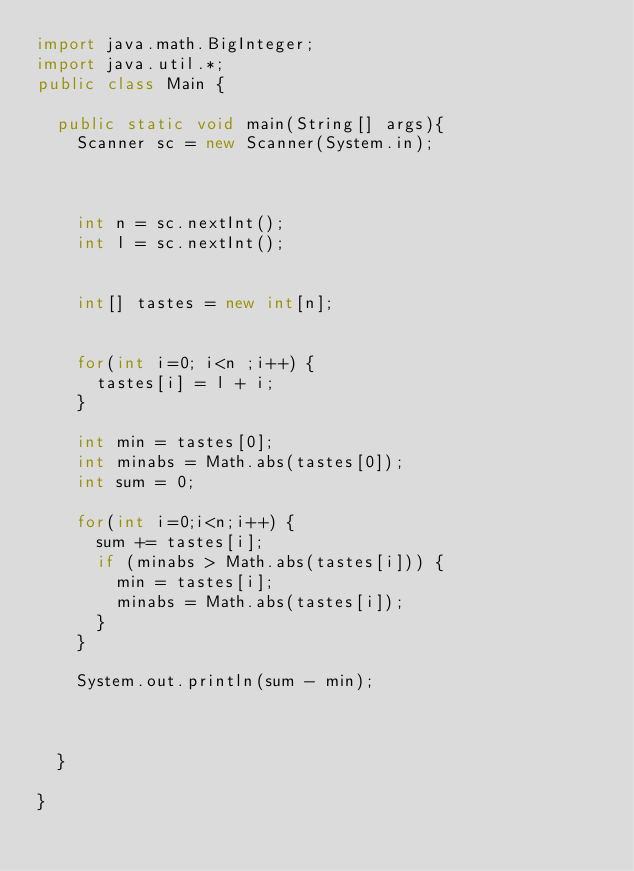<code> <loc_0><loc_0><loc_500><loc_500><_Java_>import java.math.BigInteger;
import java.util.*;
public class Main {
	
	public static void main(String[] args){
		Scanner sc = new Scanner(System.in);
		
		

		int n = sc.nextInt();
		int l = sc.nextInt();
		
		
		int[] tastes = new int[n];
	
		
		for(int i=0; i<n ;i++) {
			tastes[i] = l + i;
		}
		
		int min = tastes[0];
		int minabs = Math.abs(tastes[0]);
		int sum = 0;
		
		for(int i=0;i<n;i++) {
			sum += tastes[i];
			if (minabs > Math.abs(tastes[i])) {
				min = tastes[i];
				minabs = Math.abs(tastes[i]);
			}
		}
		
		System.out.println(sum - min);

		
		
	}
	
}

</code> 